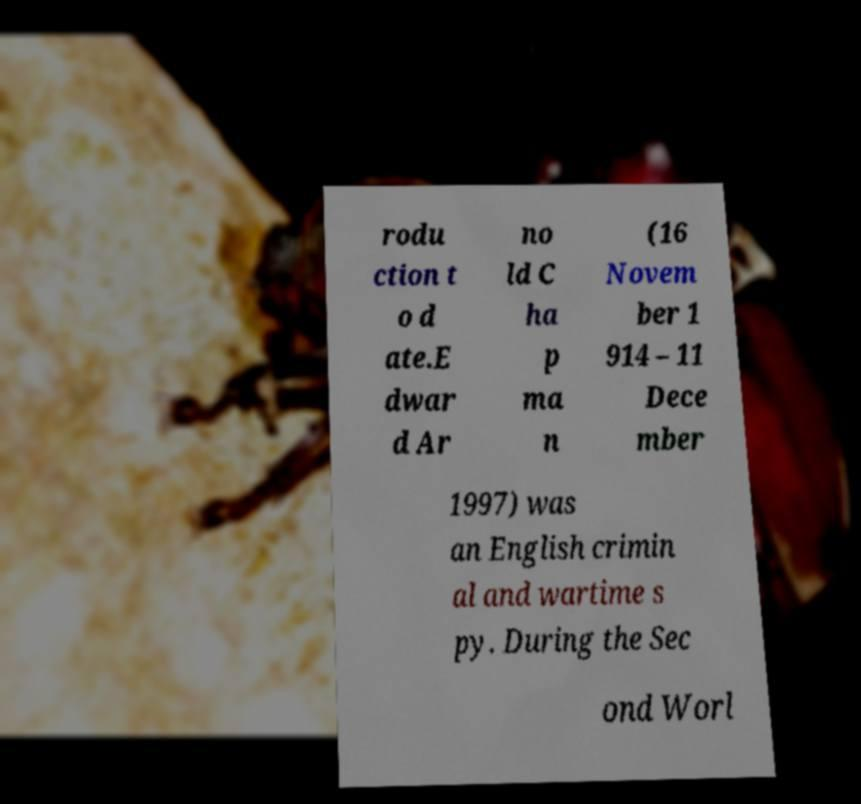There's text embedded in this image that I need extracted. Can you transcribe it verbatim? rodu ction t o d ate.E dwar d Ar no ld C ha p ma n (16 Novem ber 1 914 – 11 Dece mber 1997) was an English crimin al and wartime s py. During the Sec ond Worl 